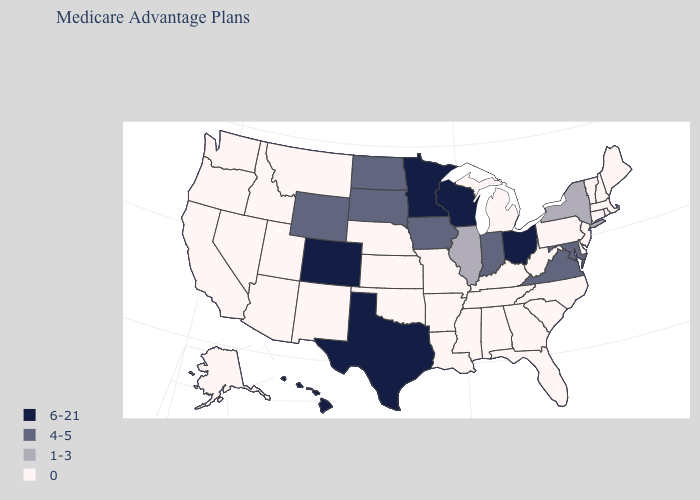Does Nebraska have the lowest value in the USA?
Quick response, please. Yes. Which states have the highest value in the USA?
Write a very short answer. Colorado, Hawaii, Minnesota, Ohio, Texas, Wisconsin. Name the states that have a value in the range 0?
Answer briefly. Alaska, Alabama, Arkansas, Arizona, California, Connecticut, Delaware, Florida, Georgia, Idaho, Kansas, Kentucky, Louisiana, Massachusetts, Maine, Michigan, Missouri, Mississippi, Montana, North Carolina, Nebraska, New Hampshire, New Jersey, New Mexico, Nevada, Oklahoma, Oregon, Pennsylvania, Rhode Island, South Carolina, Tennessee, Utah, Vermont, Washington, West Virginia. What is the value of Alaska?
Quick response, please. 0. What is the lowest value in states that border Minnesota?
Quick response, please. 4-5. What is the highest value in the South ?
Write a very short answer. 6-21. Among the states that border New Mexico , which have the lowest value?
Give a very brief answer. Arizona, Oklahoma, Utah. What is the value of Iowa?
Short answer required. 4-5. What is the value of Maryland?
Write a very short answer. 4-5. Which states have the lowest value in the Northeast?
Give a very brief answer. Connecticut, Massachusetts, Maine, New Hampshire, New Jersey, Pennsylvania, Rhode Island, Vermont. Which states have the lowest value in the West?
Keep it brief. Alaska, Arizona, California, Idaho, Montana, New Mexico, Nevada, Oregon, Utah, Washington. Name the states that have a value in the range 1-3?
Be succinct. Illinois, New York. What is the highest value in the West ?
Write a very short answer. 6-21. What is the lowest value in the USA?
Write a very short answer. 0. What is the highest value in the South ?
Give a very brief answer. 6-21. 